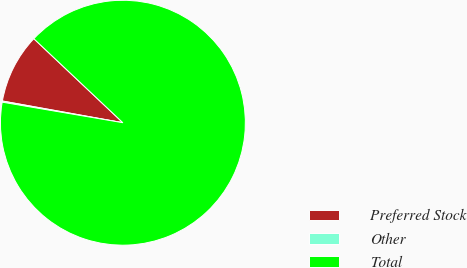Convert chart to OTSL. <chart><loc_0><loc_0><loc_500><loc_500><pie_chart><fcel>Preferred Stock<fcel>Other<fcel>Total<nl><fcel>9.2%<fcel>0.15%<fcel>90.65%<nl></chart> 